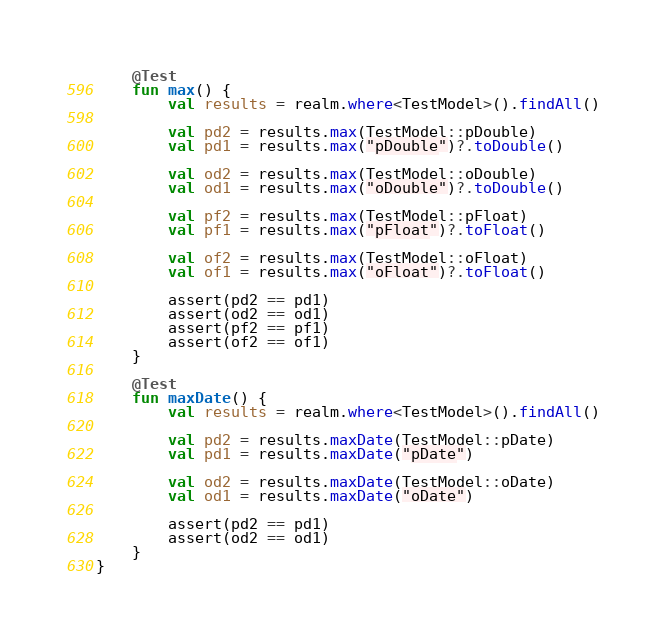<code> <loc_0><loc_0><loc_500><loc_500><_Kotlin_>
    @Test
    fun max() {
        val results = realm.where<TestModel>().findAll()

        val pd2 = results.max(TestModel::pDouble)
        val pd1 = results.max("pDouble")?.toDouble()

        val od2 = results.max(TestModel::oDouble)
        val od1 = results.max("oDouble")?.toDouble()

        val pf2 = results.max(TestModel::pFloat)
        val pf1 = results.max("pFloat")?.toFloat()

        val of2 = results.max(TestModel::oFloat)
        val of1 = results.max("oFloat")?.toFloat()

        assert(pd2 == pd1)
        assert(od2 == od1)
        assert(pf2 == pf1)
        assert(of2 == of1)
    }

    @Test
    fun maxDate() {
        val results = realm.where<TestModel>().findAll()

        val pd2 = results.maxDate(TestModel::pDate)
        val pd1 = results.maxDate("pDate")

        val od2 = results.maxDate(TestModel::oDate)
        val od1 = results.maxDate("oDate")

        assert(pd2 == pd1)
        assert(od2 == od1)
    }
}</code> 